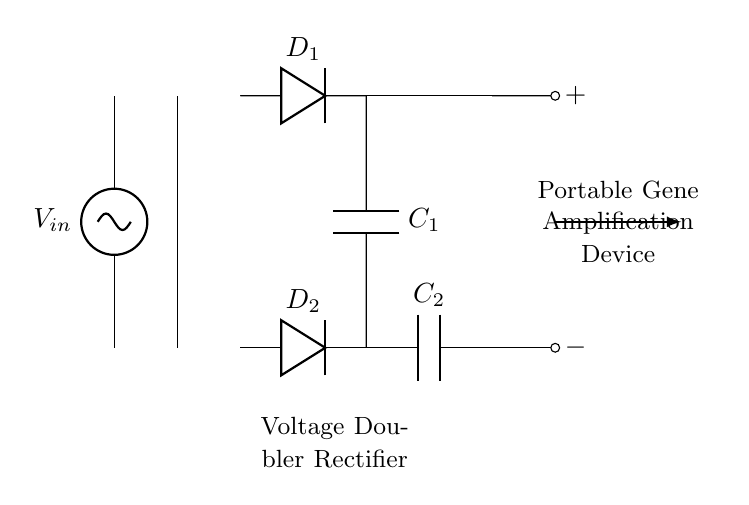What type of circuit is depicted? The circuit diagram represents a voltage doubler rectifier circuit, which is used to convert AC voltage to a higher DC voltage using a specific arrangement of diodes and capacitors.
Answer: Voltage doubler rectifier How many diodes are in the circuit? The diagram shows two diodes labeled D1 and D2, which are essential components in the rectification process of the voltage doubler circuit by allowing current to flow in one direction.
Answer: Two What is the function of the transformers in this circuit? The transformer serves to step up or step down the input AC voltage according to the desired output. It plays a critical role in modifying the input voltage before it undergoes rectification.
Answer: Transformer What do the capacitors do in this circuit? The capacitors, labeled C1 and C2, store charge after rectification, smooth the output voltage, and help achieve a higher DC voltage by accumulating energy during the charging phase of the circuit operation.
Answer: Store charge What is the output voltage type of this circuit? The output voltage is DC (Direct Current) achieved after the rectification process, which converts the input AC to a steady voltage suitable for the operation of a portable gene amplification device.
Answer: DC What connects the output of the circuit? The outputs of the circuit are connected to short components marked with positive and negative symbols, indicating the terminal points where the amplified voltage can be accessed for further use.
Answer: Short components 